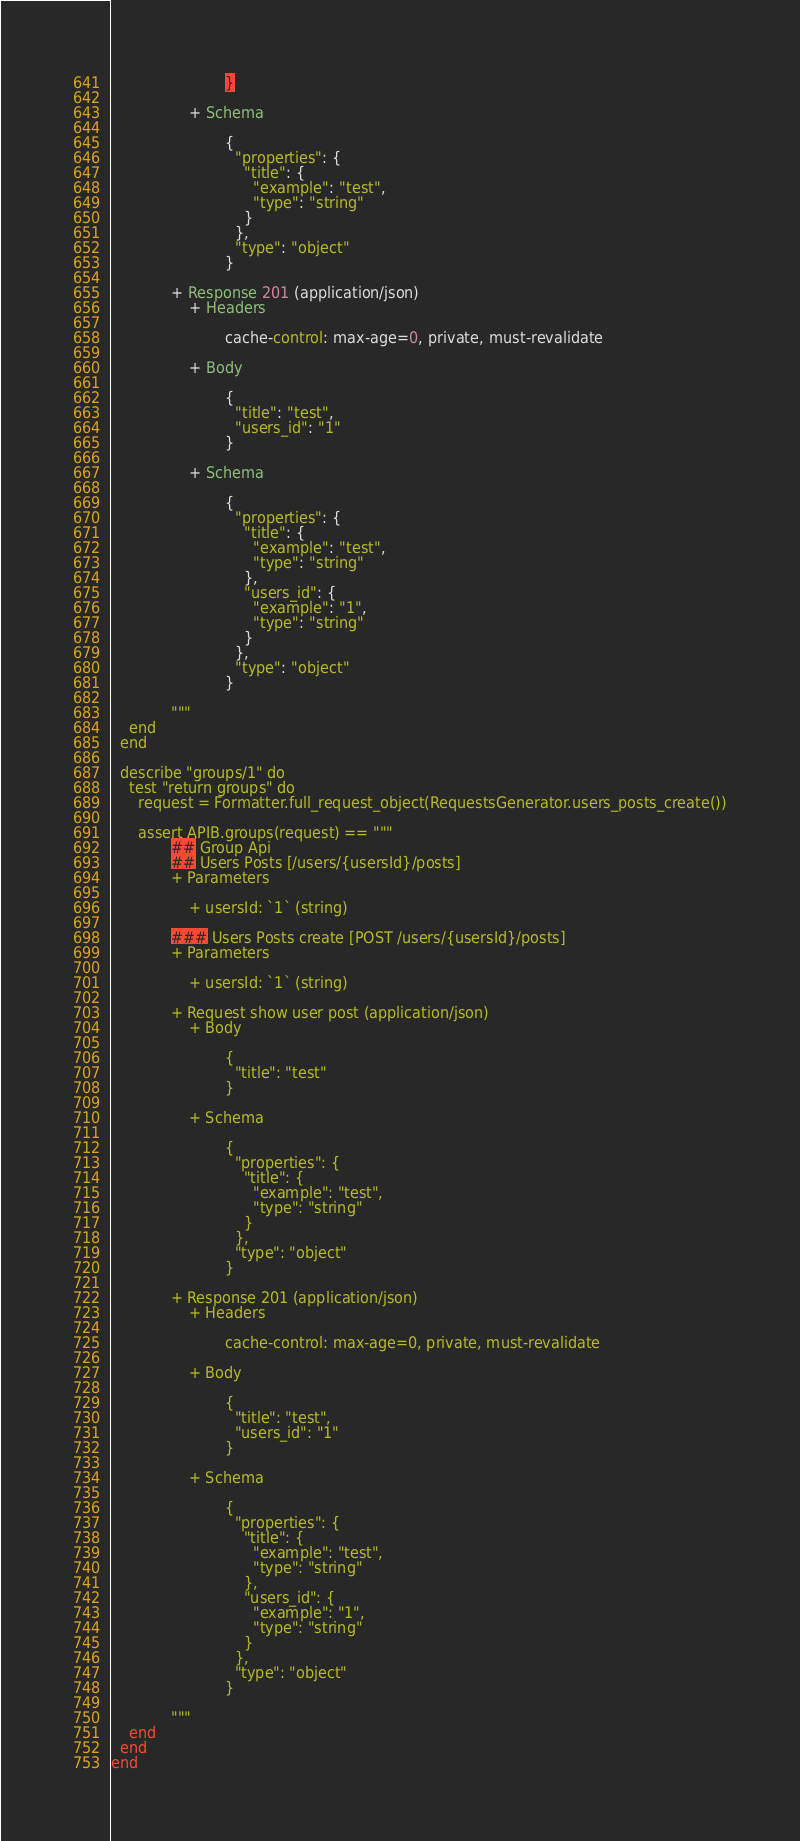Convert code to text. <code><loc_0><loc_0><loc_500><loc_500><_Elixir_>                         }

                 + Schema

                         {
                           "properties": {
                             "title": {
                               "example": "test",
                               "type": "string"
                             }
                           },
                           "type": "object"
                         }

             + Response 201 (application/json)
                 + Headers

                         cache-control: max-age=0, private, must-revalidate

                 + Body

                         {
                           "title": "test",
                           "users_id": "1"
                         }

                 + Schema

                         {
                           "properties": {
                             "title": {
                               "example": "test",
                               "type": "string"
                             },
                             "users_id": {
                               "example": "1",
                               "type": "string"
                             }
                           },
                           "type": "object"
                         }

             """
    end
  end

  describe "groups/1" do
    test "return groups" do
      request = Formatter.full_request_object(RequestsGenerator.users_posts_create())

      assert APIB.groups(request) == """
             ## Group Api
             ## Users Posts [/users/{usersId}/posts]
             + Parameters

                 + usersId: `1` (string)

             ### Users Posts create [POST /users/{usersId}/posts]
             + Parameters

                 + usersId: `1` (string)

             + Request show user post (application/json)
                 + Body

                         {
                           "title": "test"
                         }

                 + Schema

                         {
                           "properties": {
                             "title": {
                               "example": "test",
                               "type": "string"
                             }
                           },
                           "type": "object"
                         }

             + Response 201 (application/json)
                 + Headers

                         cache-control: max-age=0, private, must-revalidate

                 + Body

                         {
                           "title": "test",
                           "users_id": "1"
                         }

                 + Schema

                         {
                           "properties": {
                             "title": {
                               "example": "test",
                               "type": "string"
                             },
                             "users_id": {
                               "example": "1",
                               "type": "string"
                             }
                           },
                           "type": "object"
                         }

             """
    end
  end
end
</code> 